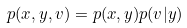Convert formula to latex. <formula><loc_0><loc_0><loc_500><loc_500>p ( x , y , v ) & = p ( x , y ) p ( v | y )</formula> 